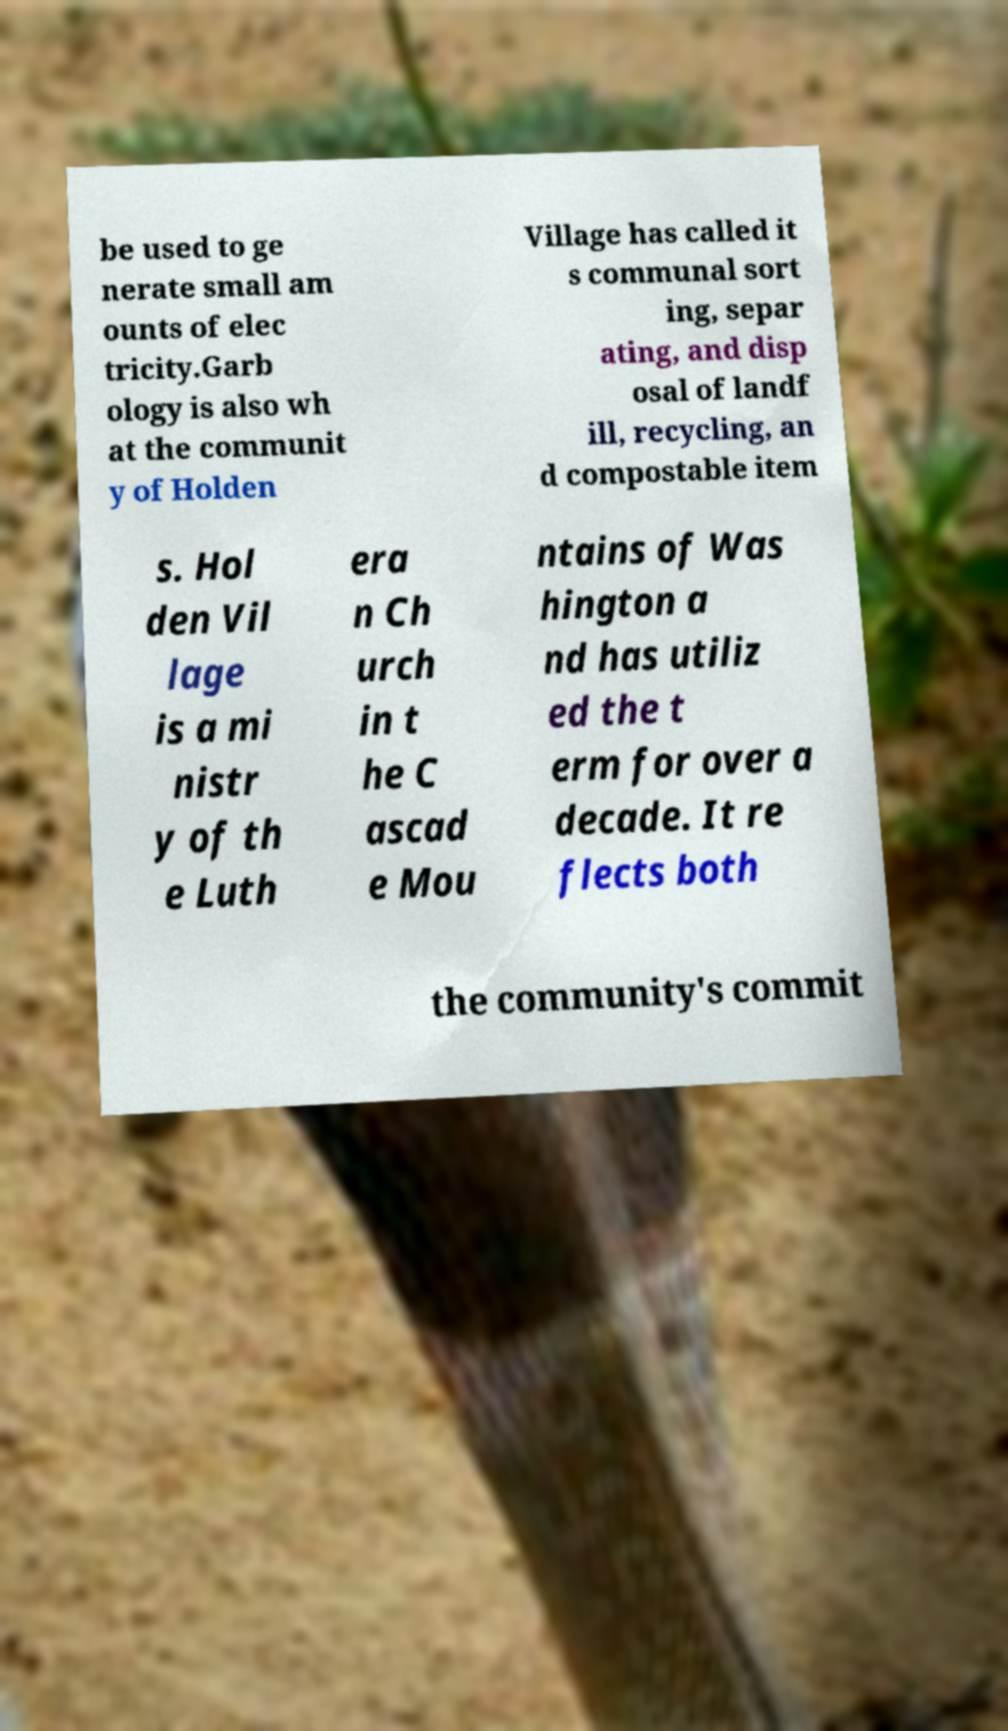Please identify and transcribe the text found in this image. be used to ge nerate small am ounts of elec tricity.Garb ology is also wh at the communit y of Holden Village has called it s communal sort ing, separ ating, and disp osal of landf ill, recycling, an d compostable item s. Hol den Vil lage is a mi nistr y of th e Luth era n Ch urch in t he C ascad e Mou ntains of Was hington a nd has utiliz ed the t erm for over a decade. It re flects both the community's commit 